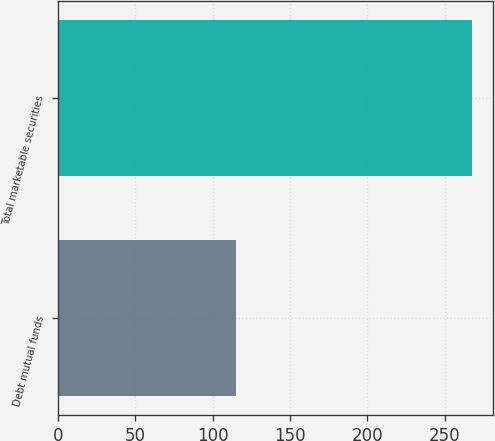Convert chart. <chart><loc_0><loc_0><loc_500><loc_500><bar_chart><fcel>Debt mutual funds<fcel>Total marketable securities<nl><fcel>115<fcel>268<nl></chart> 